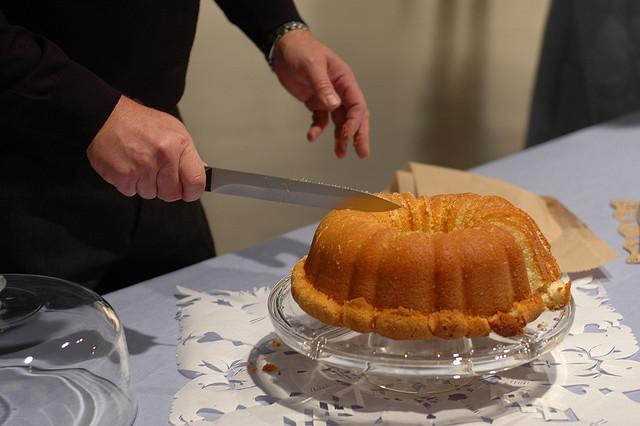What type of cake is this? Please explain your reasoning. bondt cake. This is a bundt cake. 